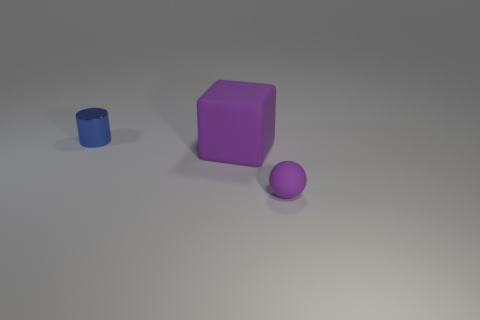What color is the metal cylinder that is the same size as the purple rubber ball?
Provide a short and direct response. Blue. What is the tiny object behind the purple matte thing behind the tiny object that is in front of the blue shiny cylinder made of?
Provide a short and direct response. Metal. What material is the big thing?
Give a very brief answer. Rubber. There is a rubber object in front of the large rubber object; is its color the same as the small thing on the left side of the large purple block?
Offer a very short reply. No. Is the number of big rubber blocks greater than the number of tiny green metallic cylinders?
Offer a very short reply. Yes. What number of tiny rubber objects are the same color as the small sphere?
Ensure brevity in your answer.  0. There is a object that is in front of the blue thing and behind the tiny purple object; what material is it made of?
Your answer should be compact. Rubber. Do the thing behind the purple block and the purple thing that is in front of the purple rubber cube have the same material?
Offer a very short reply. No. What is the size of the rubber cube?
Your answer should be compact. Large. How many cylinders are in front of the big purple thing?
Your response must be concise. 0. 